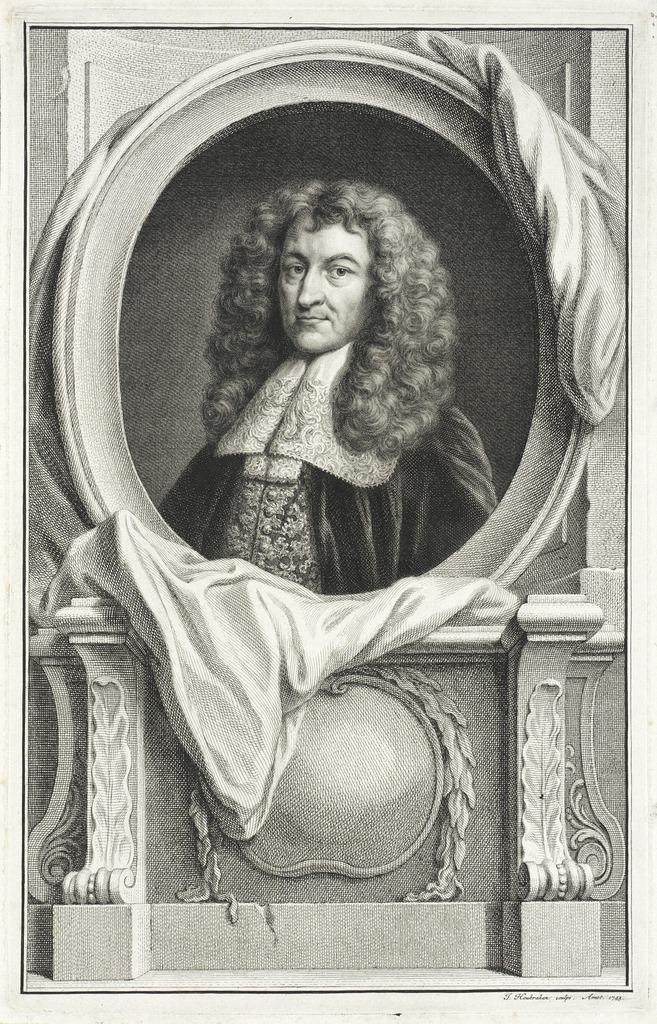How would you summarize this image in a sentence or two? In the foreground of this black and white depiction image, there is a cloth on a frame which is near a wall. 